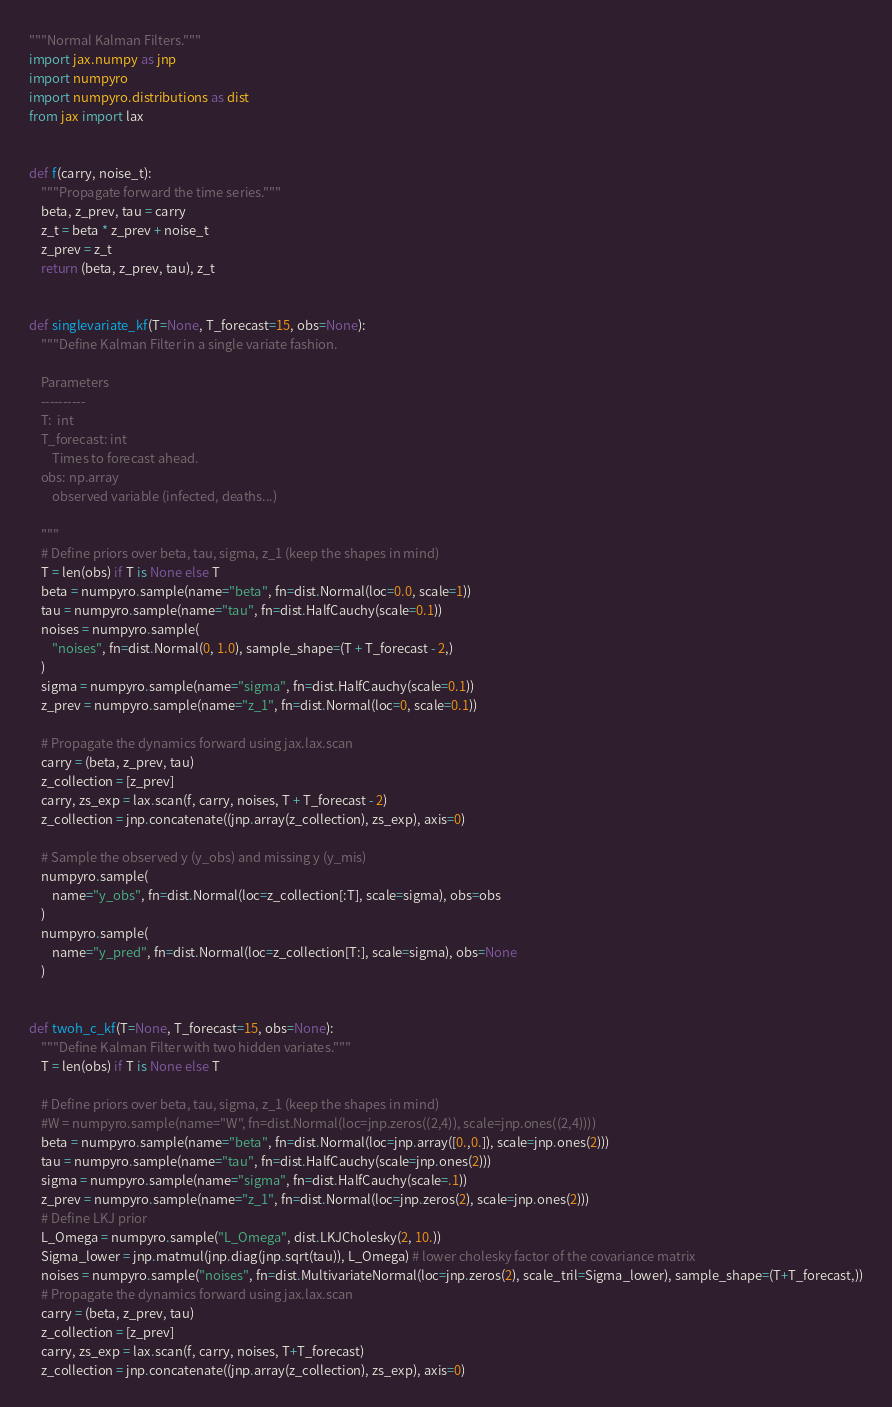<code> <loc_0><loc_0><loc_500><loc_500><_Python_>"""Normal Kalman Filters."""
import jax.numpy as jnp
import numpyro
import numpyro.distributions as dist
from jax import lax


def f(carry, noise_t):
    """Propagate forward the time series."""
    beta, z_prev, tau = carry
    z_t = beta * z_prev + noise_t
    z_prev = z_t
    return (beta, z_prev, tau), z_t


def singlevariate_kf(T=None, T_forecast=15, obs=None):
    """Define Kalman Filter in a single variate fashion.

    Parameters
    ----------
    T:  int
    T_forecast: int
        Times to forecast ahead.
    obs: np.array
        observed variable (infected, deaths...)

    """
    # Define priors over beta, tau, sigma, z_1 (keep the shapes in mind)
    T = len(obs) if T is None else T
    beta = numpyro.sample(name="beta", fn=dist.Normal(loc=0.0, scale=1))
    tau = numpyro.sample(name="tau", fn=dist.HalfCauchy(scale=0.1))
    noises = numpyro.sample(
        "noises", fn=dist.Normal(0, 1.0), sample_shape=(T + T_forecast - 2,)
    )
    sigma = numpyro.sample(name="sigma", fn=dist.HalfCauchy(scale=0.1))
    z_prev = numpyro.sample(name="z_1", fn=dist.Normal(loc=0, scale=0.1))

    # Propagate the dynamics forward using jax.lax.scan
    carry = (beta, z_prev, tau)
    z_collection = [z_prev]
    carry, zs_exp = lax.scan(f, carry, noises, T + T_forecast - 2)
    z_collection = jnp.concatenate((jnp.array(z_collection), zs_exp), axis=0)

    # Sample the observed y (y_obs) and missing y (y_mis)
    numpyro.sample(
        name="y_obs", fn=dist.Normal(loc=z_collection[:T], scale=sigma), obs=obs
    )
    numpyro.sample(
        name="y_pred", fn=dist.Normal(loc=z_collection[T:], scale=sigma), obs=None
    )


def twoh_c_kf(T=None, T_forecast=15, obs=None):
    """Define Kalman Filter with two hidden variates."""
    T = len(obs) if T is None else T
    
    # Define priors over beta, tau, sigma, z_1 (keep the shapes in mind)
    #W = numpyro.sample(name="W", fn=dist.Normal(loc=jnp.zeros((2,4)), scale=jnp.ones((2,4))))
    beta = numpyro.sample(name="beta", fn=dist.Normal(loc=jnp.array([0.,0.]), scale=jnp.ones(2)))
    tau = numpyro.sample(name="tau", fn=dist.HalfCauchy(scale=jnp.ones(2)))
    sigma = numpyro.sample(name="sigma", fn=dist.HalfCauchy(scale=.1))
    z_prev = numpyro.sample(name="z_1", fn=dist.Normal(loc=jnp.zeros(2), scale=jnp.ones(2)))
    # Define LKJ prior
    L_Omega = numpyro.sample("L_Omega", dist.LKJCholesky(2, 10.))
    Sigma_lower = jnp.matmul(jnp.diag(jnp.sqrt(tau)), L_Omega) # lower cholesky factor of the covariance matrix
    noises = numpyro.sample("noises", fn=dist.MultivariateNormal(loc=jnp.zeros(2), scale_tril=Sigma_lower), sample_shape=(T+T_forecast,))
    # Propagate the dynamics forward using jax.lax.scan
    carry = (beta, z_prev, tau)
    z_collection = [z_prev]
    carry, zs_exp = lax.scan(f, carry, noises, T+T_forecast)
    z_collection = jnp.concatenate((jnp.array(z_collection), zs_exp), axis=0)
</code> 